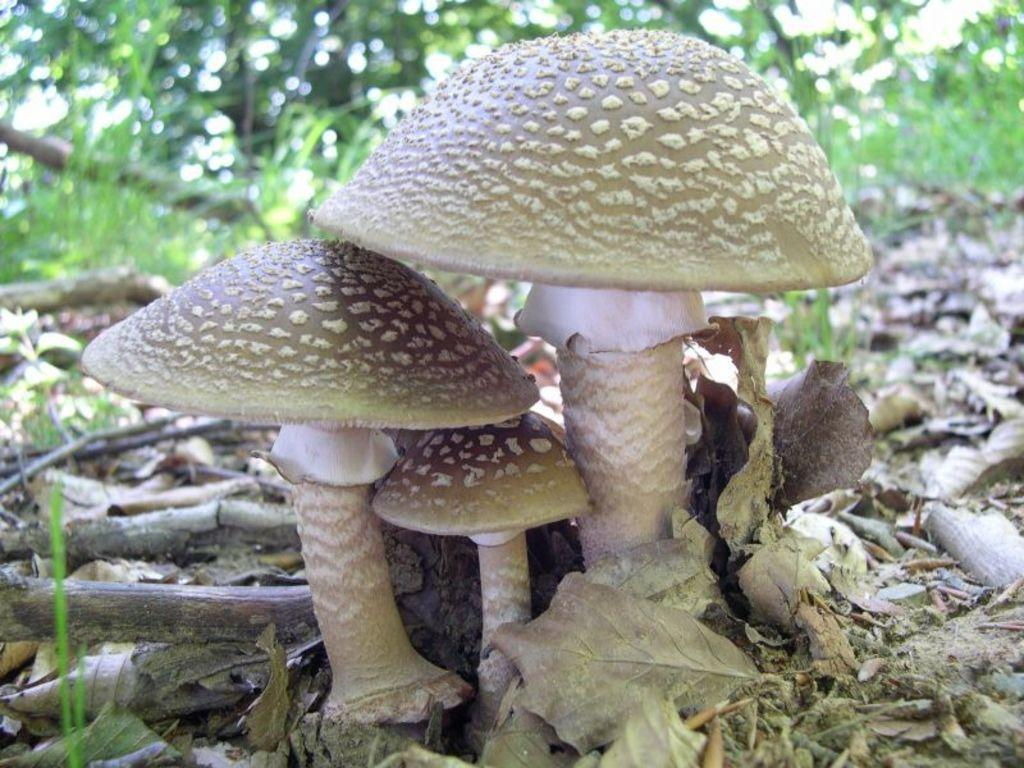What is located in the center of the image? There are mushrooms, sticks, and dry leaves in the center of the image. What can be seen in the background of the image? There are trees, grass, and a few other objects in the background of the image. What type of bag can be seen hanging from the tree in the image? There is no bag present in the image; it only features mushrooms, sticks, dry leaves, trees, grass, and other unspecified objects in the background. 